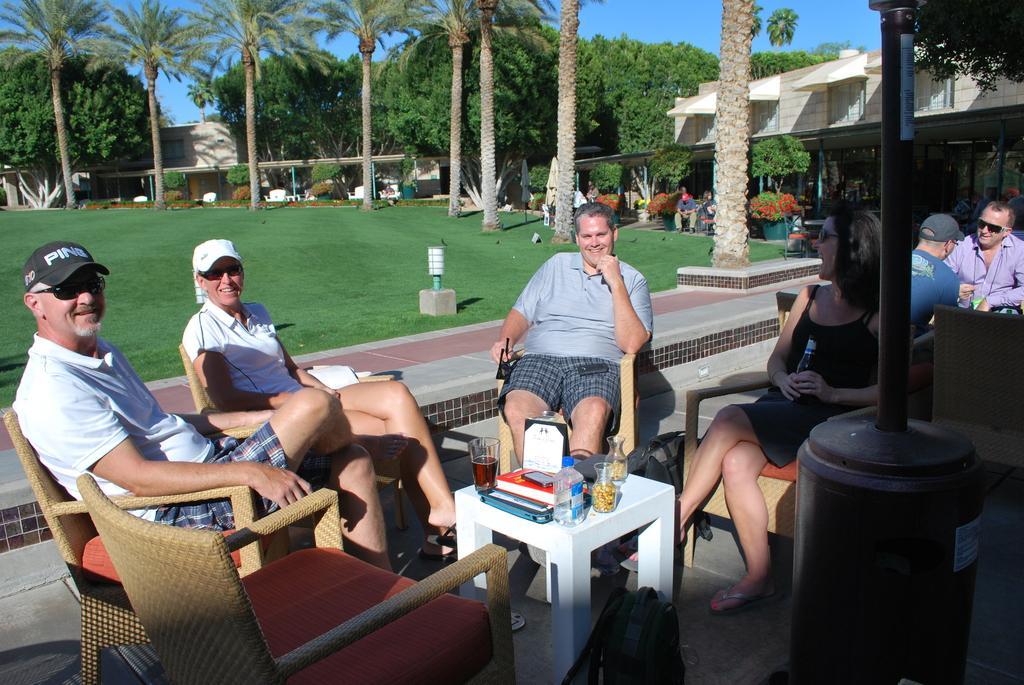Describe this image in one or two sentences. In this picture there are many people sitting on the table and there are food eatables on top of a white table , in the background we observe many trees and small buildings. The picture is clicked in a resort. 